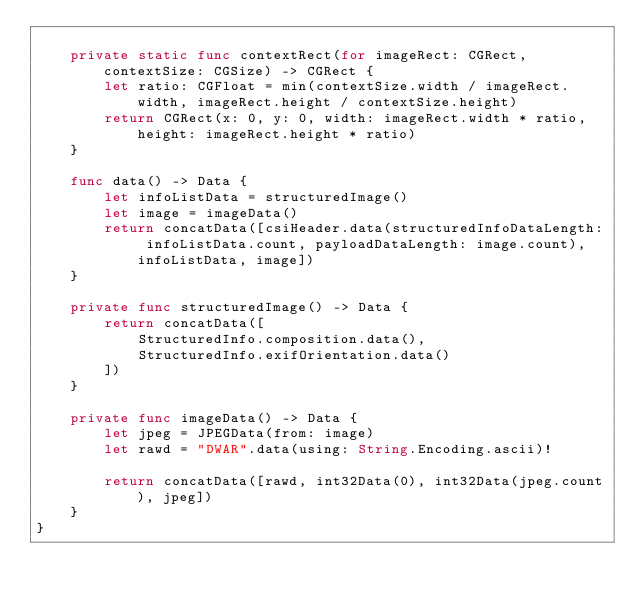Convert code to text. <code><loc_0><loc_0><loc_500><loc_500><_Swift_>    
    private static func contextRect(for imageRect: CGRect, contextSize: CGSize) -> CGRect {
        let ratio: CGFloat = min(contextSize.width / imageRect.width, imageRect.height / contextSize.height)
        return CGRect(x: 0, y: 0, width: imageRect.width * ratio, height: imageRect.height * ratio)
    }
    
    func data() -> Data {
        let infoListData = structuredImage()
        let image = imageData()
        return concatData([csiHeader.data(structuredInfoDataLength: infoListData.count, payloadDataLength: image.count), infoListData, image])
    }
    
    private func structuredImage() -> Data {
        return concatData([
            StructuredInfo.composition.data(),
            StructuredInfo.exifOrientation.data()
        ])
    }
    
    private func imageData() -> Data {
        let jpeg = JPEGData(from: image)
        let rawd = "DWAR".data(using: String.Encoding.ascii)!
        
        return concatData([rawd, int32Data(0), int32Data(jpeg.count), jpeg])
    }
}
</code> 